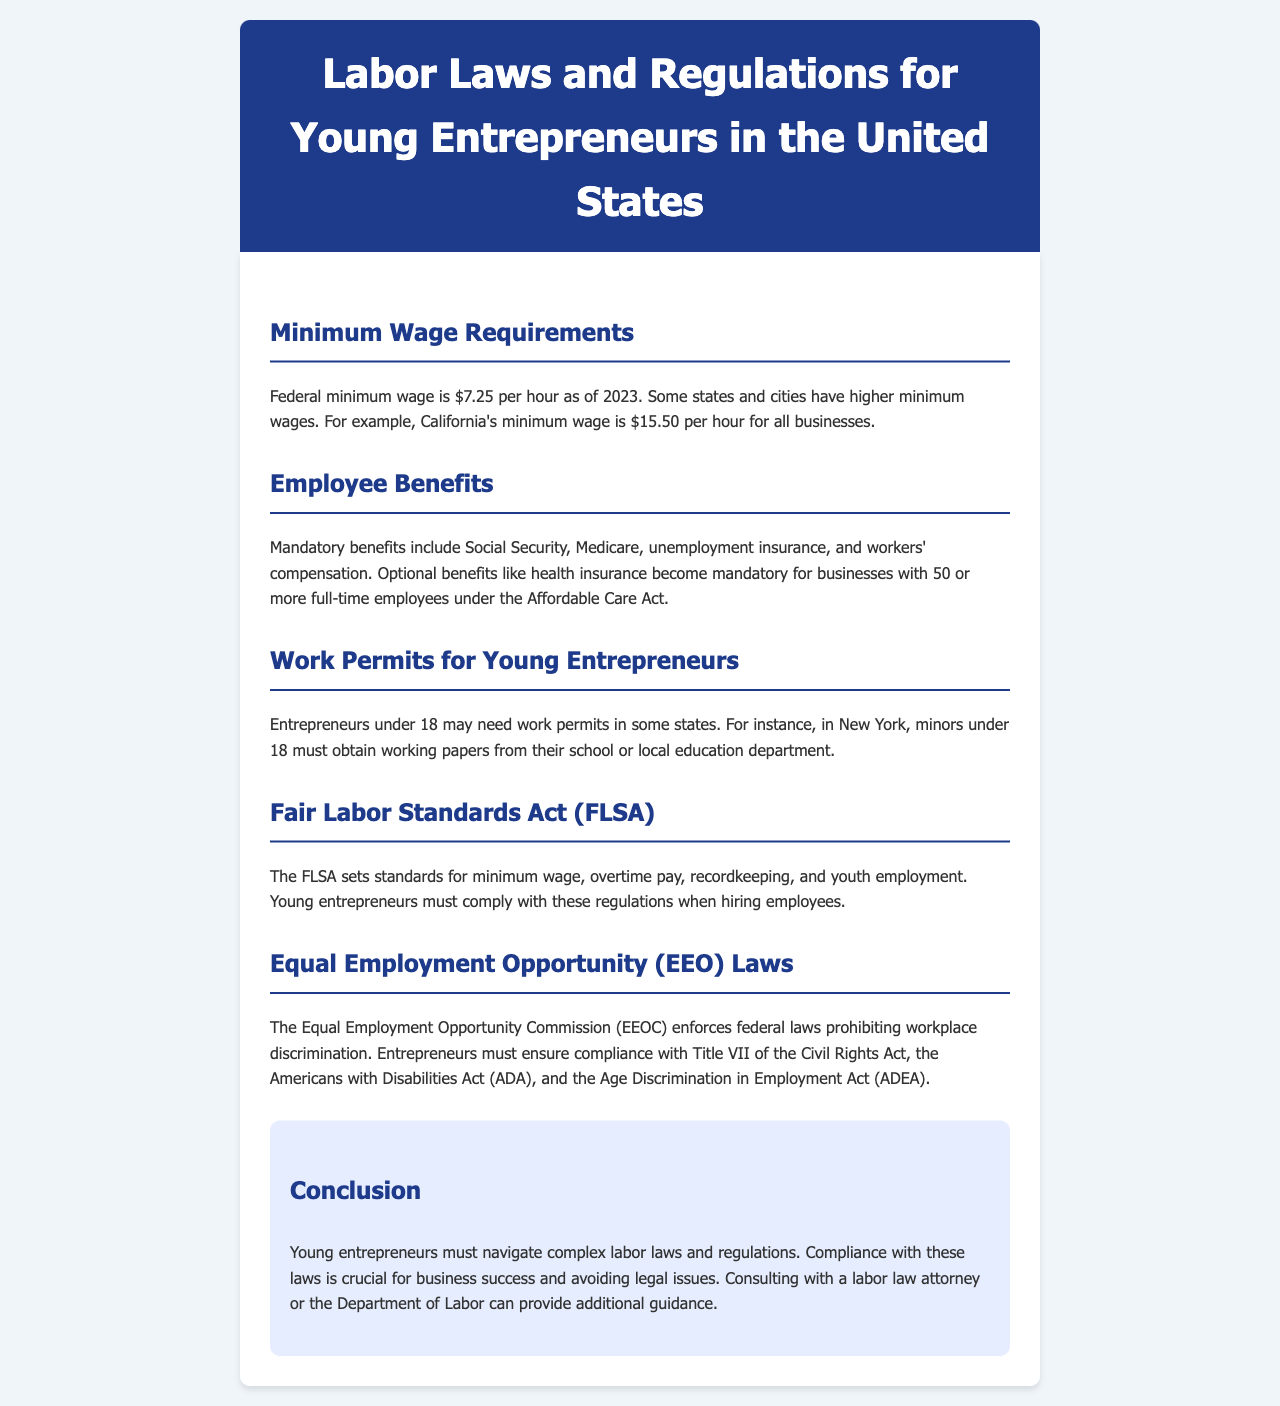What is the federal minimum wage as of 2023? The document states that the federal minimum wage is $7.25 per hour as of 2023.
Answer: $7.25 What is California's minimum wage? The document indicates that California's minimum wage is $15.50 per hour for all businesses.
Answer: $15.50 What benefits are mandatory for employers? The document lists mandatory benefits including Social Security, Medicare, unemployment insurance, and workers' compensation.
Answer: Social Security, Medicare, unemployment insurance, workers' compensation At what age may entrepreneurs need a work permit in some states? The document mentions that entrepreneurs under 18 may need work permits in some states.
Answer: Under 18 What does the FLSA establish standards for? The FLSA sets standards for minimum wage, overtime pay, recordkeeping, and youth employment.
Answer: Minimum wage, overtime pay, recordkeeping, youth employment Which commission enforces federal laws prohibiting workplace discrimination? The document states that the Equal Employment Opportunity Commission (EEOC) enforces federal laws prohibiting workplace discrimination.
Answer: Equal Employment Opportunity Commission (EEOC) What advice is given for compliance with labor laws? The document advises consulting with a labor law attorney or the Department of Labor for additional guidance.
Answer: Consulting with a labor law attorney or the Department of Labor 